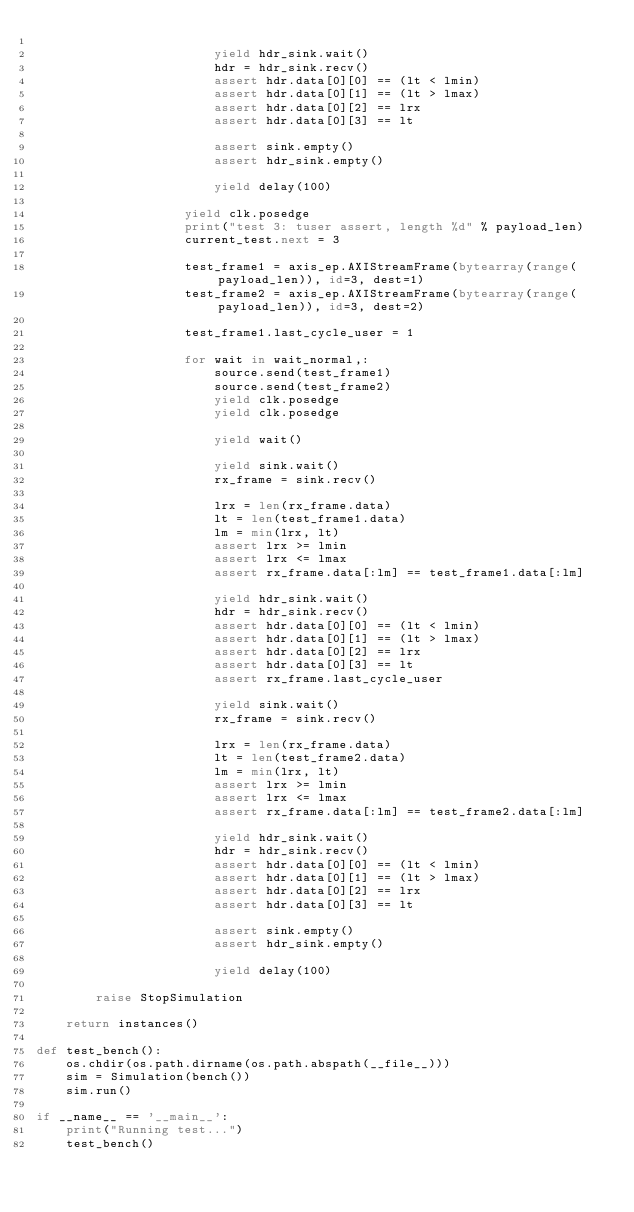Convert code to text. <code><loc_0><loc_0><loc_500><loc_500><_Python_>
                        yield hdr_sink.wait()
                        hdr = hdr_sink.recv()
                        assert hdr.data[0][0] == (lt < lmin)
                        assert hdr.data[0][1] == (lt > lmax)
                        assert hdr.data[0][2] == lrx
                        assert hdr.data[0][3] == lt

                        assert sink.empty()
                        assert hdr_sink.empty()

                        yield delay(100)

                    yield clk.posedge
                    print("test 3: tuser assert, length %d" % payload_len)
                    current_test.next = 3

                    test_frame1 = axis_ep.AXIStreamFrame(bytearray(range(payload_len)), id=3, dest=1)
                    test_frame2 = axis_ep.AXIStreamFrame(bytearray(range(payload_len)), id=3, dest=2)

                    test_frame1.last_cycle_user = 1

                    for wait in wait_normal,:
                        source.send(test_frame1)
                        source.send(test_frame2)
                        yield clk.posedge
                        yield clk.posedge

                        yield wait()

                        yield sink.wait()
                        rx_frame = sink.recv()

                        lrx = len(rx_frame.data)
                        lt = len(test_frame1.data)
                        lm = min(lrx, lt)
                        assert lrx >= lmin
                        assert lrx <= lmax
                        assert rx_frame.data[:lm] == test_frame1.data[:lm]

                        yield hdr_sink.wait()
                        hdr = hdr_sink.recv()
                        assert hdr.data[0][0] == (lt < lmin)
                        assert hdr.data[0][1] == (lt > lmax)
                        assert hdr.data[0][2] == lrx
                        assert hdr.data[0][3] == lt
                        assert rx_frame.last_cycle_user

                        yield sink.wait()
                        rx_frame = sink.recv()

                        lrx = len(rx_frame.data)
                        lt = len(test_frame2.data)
                        lm = min(lrx, lt)
                        assert lrx >= lmin
                        assert lrx <= lmax
                        assert rx_frame.data[:lm] == test_frame2.data[:lm]

                        yield hdr_sink.wait()
                        hdr = hdr_sink.recv()
                        assert hdr.data[0][0] == (lt < lmin)
                        assert hdr.data[0][1] == (lt > lmax)
                        assert hdr.data[0][2] == lrx
                        assert hdr.data[0][3] == lt

                        assert sink.empty()
                        assert hdr_sink.empty()

                        yield delay(100)

        raise StopSimulation

    return instances()

def test_bench():
    os.chdir(os.path.dirname(os.path.abspath(__file__)))
    sim = Simulation(bench())
    sim.run()

if __name__ == '__main__':
    print("Running test...")
    test_bench()

</code> 